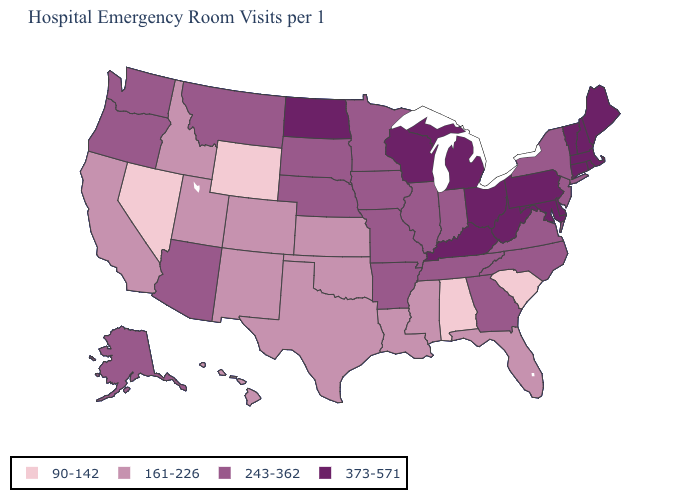Does Texas have the same value as South Carolina?
Concise answer only. No. Name the states that have a value in the range 90-142?
Be succinct. Alabama, Nevada, South Carolina, Wyoming. What is the value of New York?
Answer briefly. 243-362. Among the states that border California , does Nevada have the highest value?
Give a very brief answer. No. Name the states that have a value in the range 243-362?
Answer briefly. Alaska, Arizona, Arkansas, Georgia, Illinois, Indiana, Iowa, Minnesota, Missouri, Montana, Nebraska, New Jersey, New York, North Carolina, Oregon, South Dakota, Tennessee, Virginia, Washington. What is the highest value in the USA?
Concise answer only. 373-571. Does Nevada have the lowest value in the West?
Short answer required. Yes. What is the highest value in the MidWest ?
Keep it brief. 373-571. Does New Mexico have a lower value than New York?
Concise answer only. Yes. Is the legend a continuous bar?
Write a very short answer. No. Among the states that border Illinois , which have the highest value?
Quick response, please. Kentucky, Wisconsin. What is the value of Arkansas?
Short answer required. 243-362. Name the states that have a value in the range 90-142?
Short answer required. Alabama, Nevada, South Carolina, Wyoming. Is the legend a continuous bar?
Keep it brief. No. 